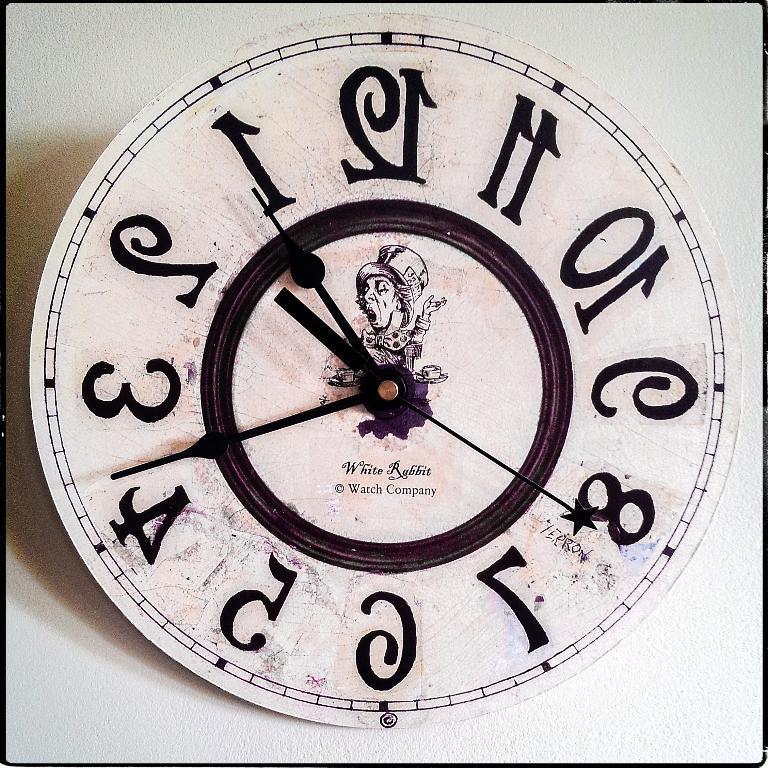Could you give a brief overview of what you see in this image? In this image we can see the clock and there is some text and numbers on it. We can see a cartoon image. 